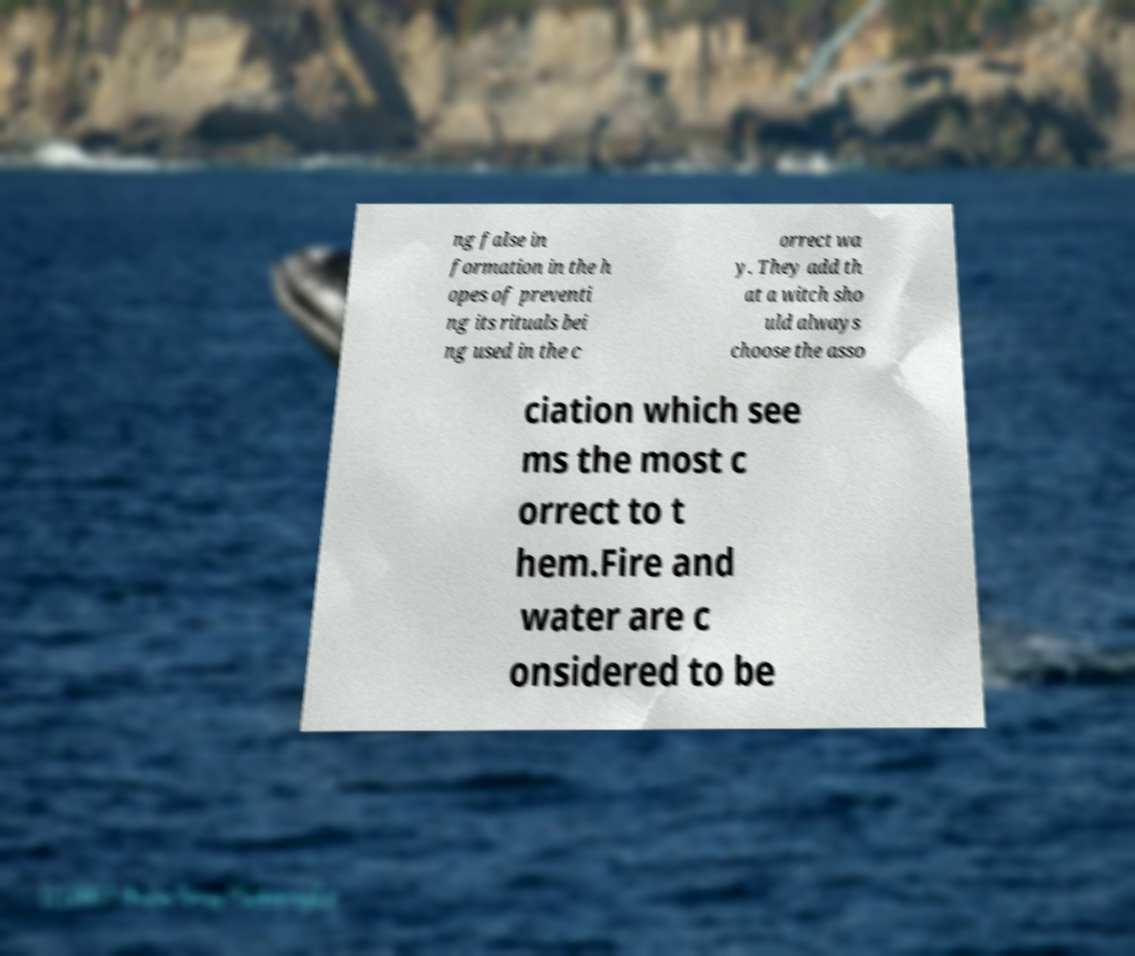There's text embedded in this image that I need extracted. Can you transcribe it verbatim? ng false in formation in the h opes of preventi ng its rituals bei ng used in the c orrect wa y. They add th at a witch sho uld always choose the asso ciation which see ms the most c orrect to t hem.Fire and water are c onsidered to be 